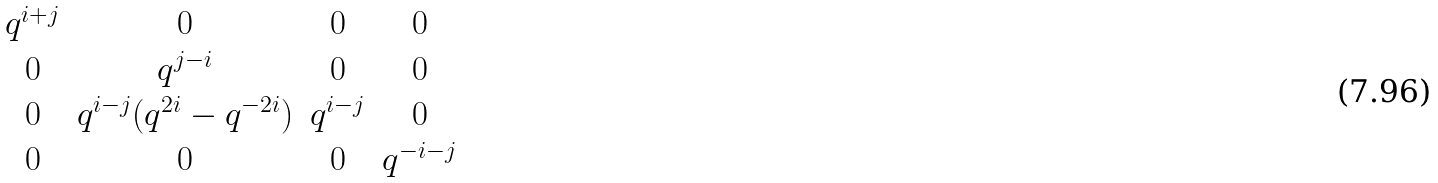Convert formula to latex. <formula><loc_0><loc_0><loc_500><loc_500>\begin{matrix} q ^ { i + j } & 0 & 0 & 0 \\ 0 & q ^ { j - i } & 0 & 0 \\ 0 & q ^ { i - j } ( q ^ { 2 i } - q ^ { - 2 i } ) & q ^ { i - j } & 0 \\ 0 & 0 & 0 & q ^ { - i - j } \end{matrix}</formula> 